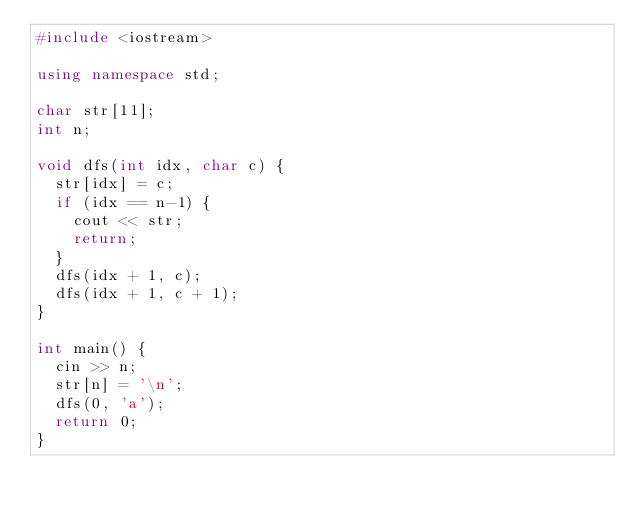<code> <loc_0><loc_0><loc_500><loc_500><_C++_>#include <iostream>

using namespace std;

char str[11];
int n;

void dfs(int idx, char c) {
	str[idx] = c;
	if (idx == n-1) {
		cout << str;
		return;
	}
	dfs(idx + 1, c);
	dfs(idx + 1, c + 1);
}

int main() {
	cin >> n;
	str[n] = '\n';
	dfs(0, 'a');
	return 0;
}</code> 